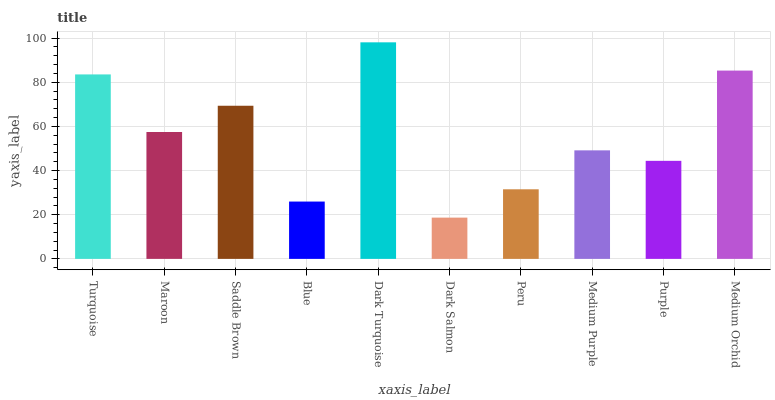Is Dark Salmon the minimum?
Answer yes or no. Yes. Is Dark Turquoise the maximum?
Answer yes or no. Yes. Is Maroon the minimum?
Answer yes or no. No. Is Maroon the maximum?
Answer yes or no. No. Is Turquoise greater than Maroon?
Answer yes or no. Yes. Is Maroon less than Turquoise?
Answer yes or no. Yes. Is Maroon greater than Turquoise?
Answer yes or no. No. Is Turquoise less than Maroon?
Answer yes or no. No. Is Maroon the high median?
Answer yes or no. Yes. Is Medium Purple the low median?
Answer yes or no. Yes. Is Turquoise the high median?
Answer yes or no. No. Is Purple the low median?
Answer yes or no. No. 